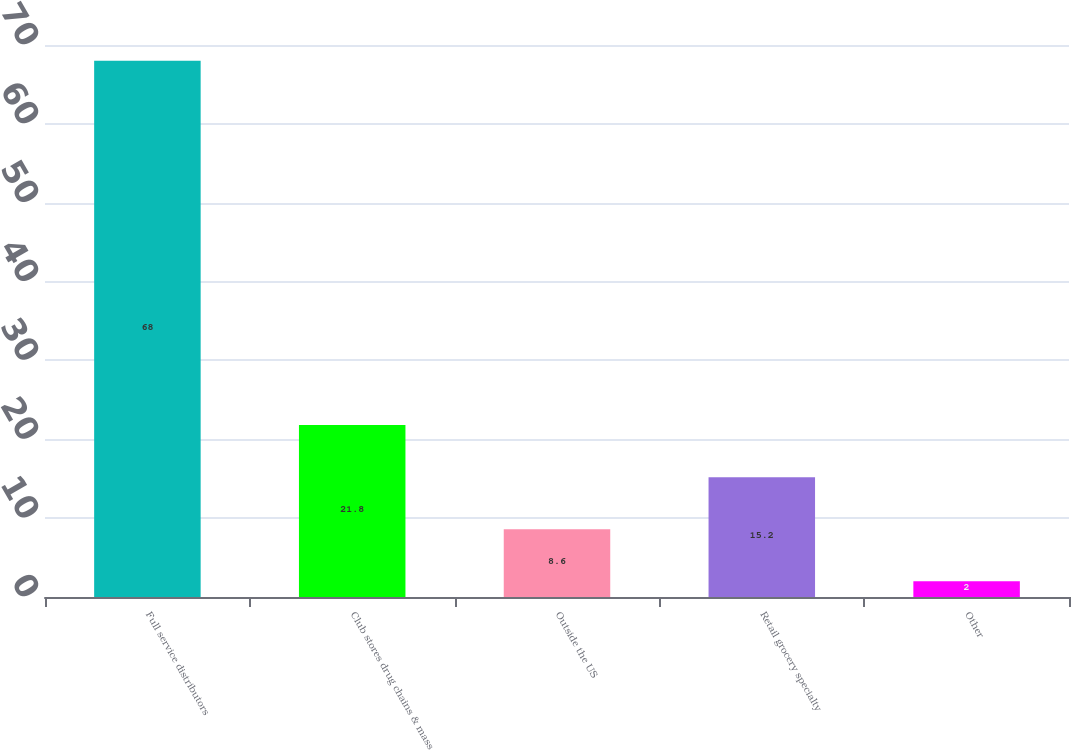<chart> <loc_0><loc_0><loc_500><loc_500><bar_chart><fcel>Full service distributors<fcel>Club stores drug chains & mass<fcel>Outside the US<fcel>Retail grocery specialty<fcel>Other<nl><fcel>68<fcel>21.8<fcel>8.6<fcel>15.2<fcel>2<nl></chart> 